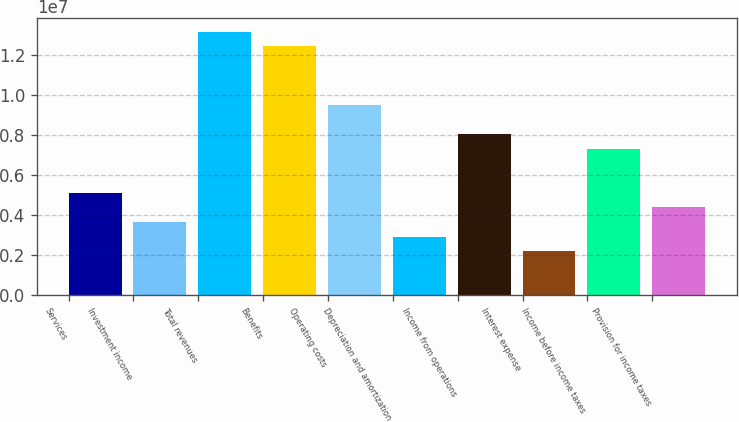Convert chart. <chart><loc_0><loc_0><loc_500><loc_500><bar_chart><fcel>Services<fcel>Investment income<fcel>Total revenues<fcel>Benefits<fcel>Operating costs<fcel>Depreciation and amortization<fcel>Income from operations<fcel>Interest expense<fcel>Income before income taxes<fcel>Provision for income taxes<nl><fcel>5.12057e+06<fcel>3.65755e+06<fcel>1.31672e+07<fcel>1.24357e+07<fcel>9.50963e+06<fcel>2.92605e+06<fcel>8.04661e+06<fcel>2.19454e+06<fcel>7.3151e+06<fcel>4.38906e+06<nl></chart> 